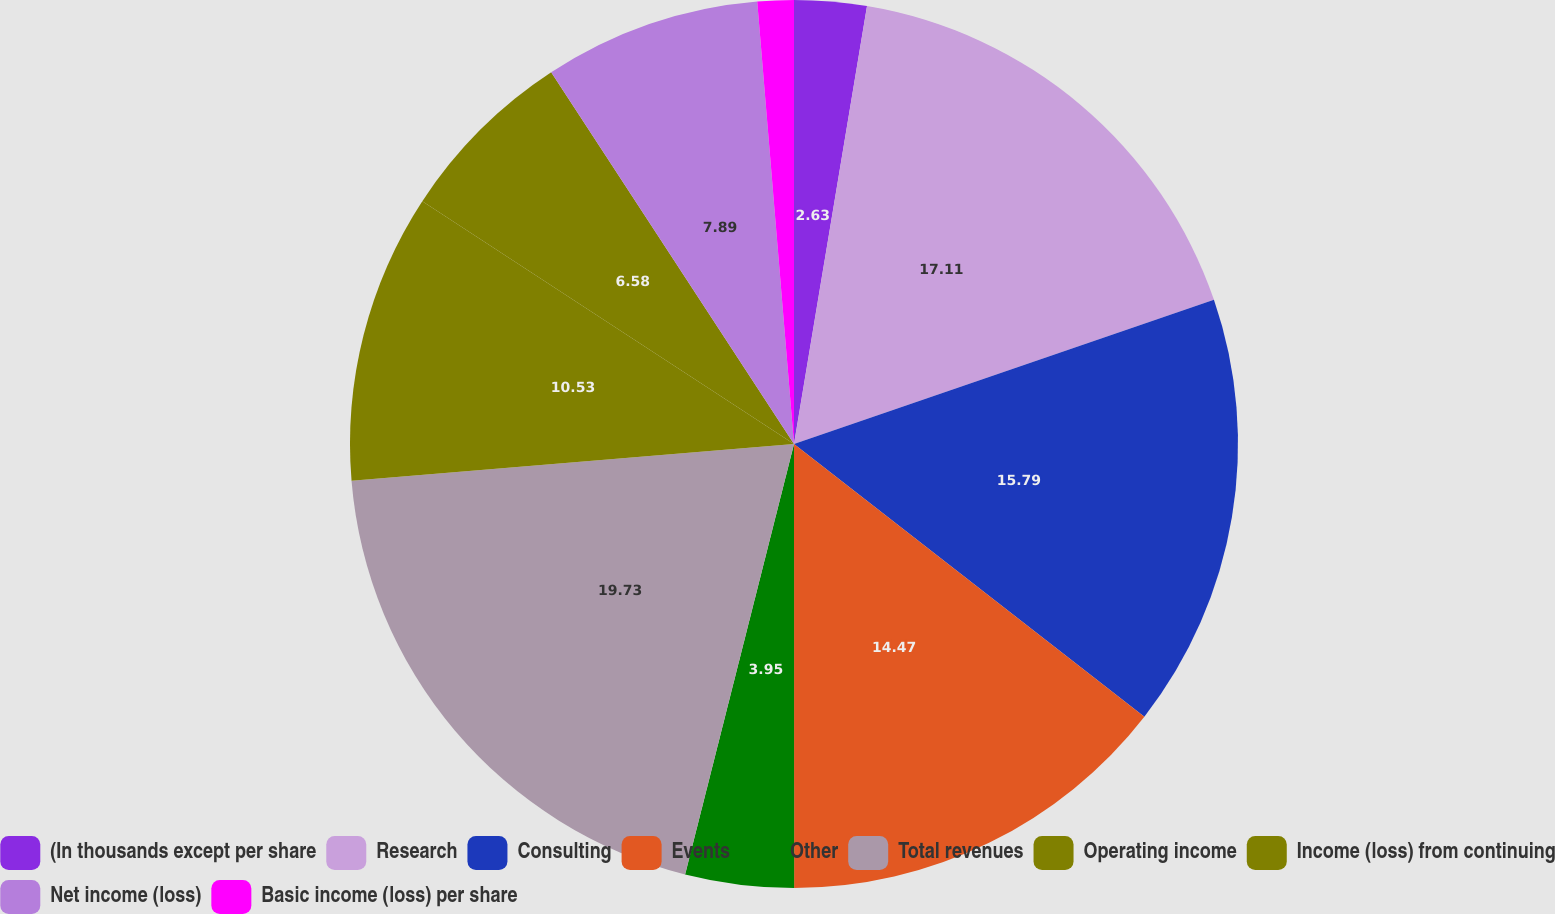Convert chart to OTSL. <chart><loc_0><loc_0><loc_500><loc_500><pie_chart><fcel>(In thousands except per share<fcel>Research<fcel>Consulting<fcel>Events<fcel>Other<fcel>Total revenues<fcel>Operating income<fcel>Income (loss) from continuing<fcel>Net income (loss)<fcel>Basic income (loss) per share<nl><fcel>2.63%<fcel>17.11%<fcel>15.79%<fcel>14.47%<fcel>3.95%<fcel>19.74%<fcel>10.53%<fcel>6.58%<fcel>7.89%<fcel>1.32%<nl></chart> 